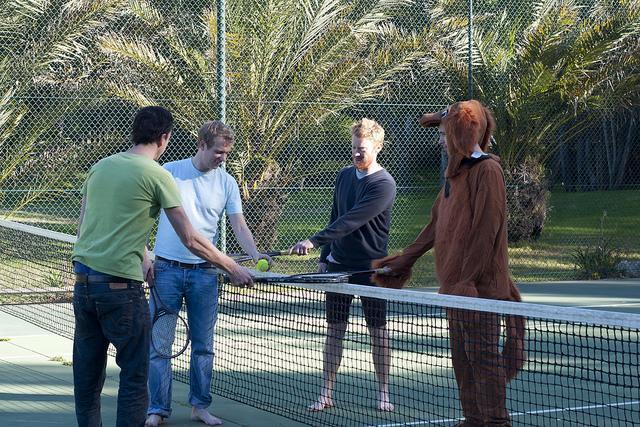How many people are in this image?
Give a very brief answer. 4. How many people are there?
Give a very brief answer. 4. 